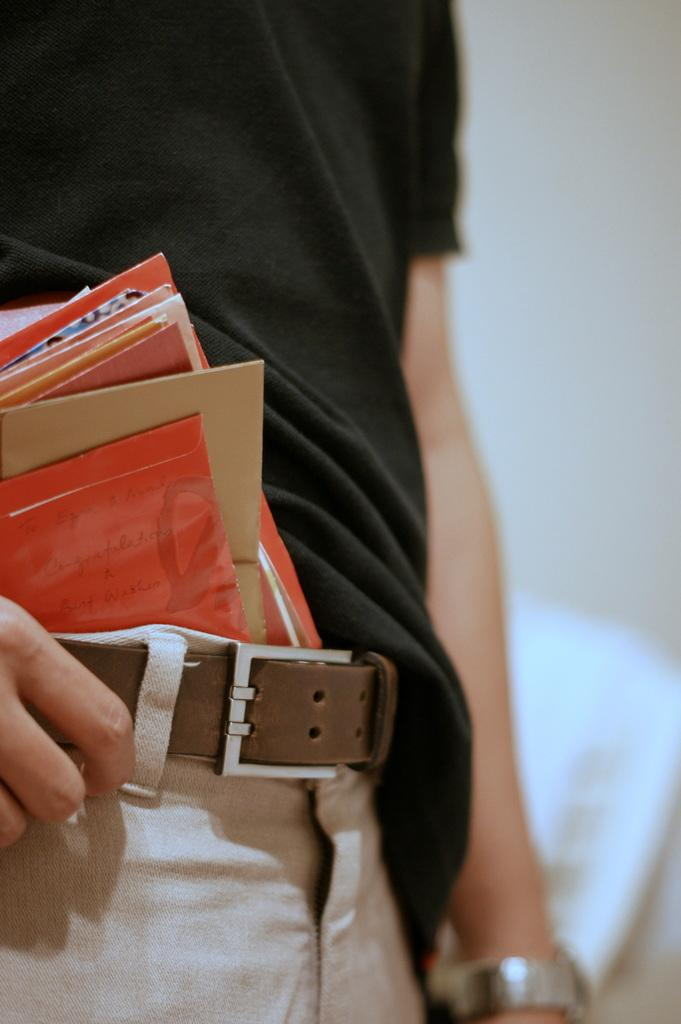What is the main subject of the image? There is a person standing in the image. What is the person wearing? The person is wearing a black t-shirt. What can be seen on the left side of the image? There are papers on the left side of the image. How many apples are on the horse in the image? There is no horse or apples present in the image. 